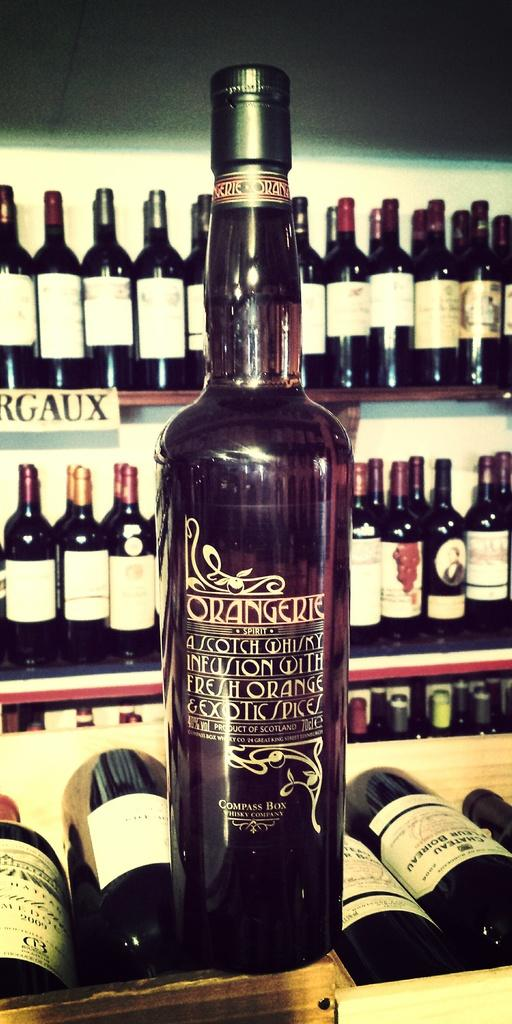What is on the desk in the image? There is a wine bottle on the desk in the image. Where are additional wine bottles located in the image? There are wine bottles placed in racks in the image. What can be seen in the background of the image? There is a wall visible in the background of the image. How many family members are present in the image? There is no indication of family members in the image; it primarily features wine bottles and a wall in the background. 